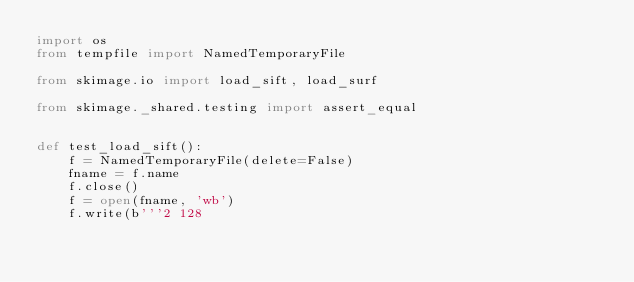Convert code to text. <code><loc_0><loc_0><loc_500><loc_500><_Python_>import os
from tempfile import NamedTemporaryFile

from skimage.io import load_sift, load_surf

from skimage._shared.testing import assert_equal


def test_load_sift():
    f = NamedTemporaryFile(delete=False)
    fname = f.name
    f.close()
    f = open(fname, 'wb')
    f.write(b'''2 128</code> 